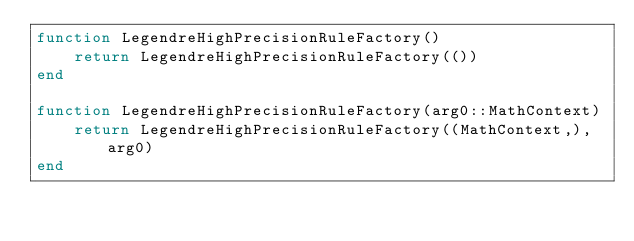Convert code to text. <code><loc_0><loc_0><loc_500><loc_500><_Julia_>function LegendreHighPrecisionRuleFactory()
    return LegendreHighPrecisionRuleFactory(())
end

function LegendreHighPrecisionRuleFactory(arg0::MathContext)
    return LegendreHighPrecisionRuleFactory((MathContext,), arg0)
end

</code> 